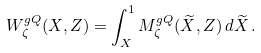<formula> <loc_0><loc_0><loc_500><loc_500>W ^ { g Q } _ { \zeta } ( X , Z ) = \int _ { X } ^ { 1 } M ^ { g Q } _ { \zeta } ( \widetilde { X } , Z ) \, d \widetilde { X } \, .</formula> 